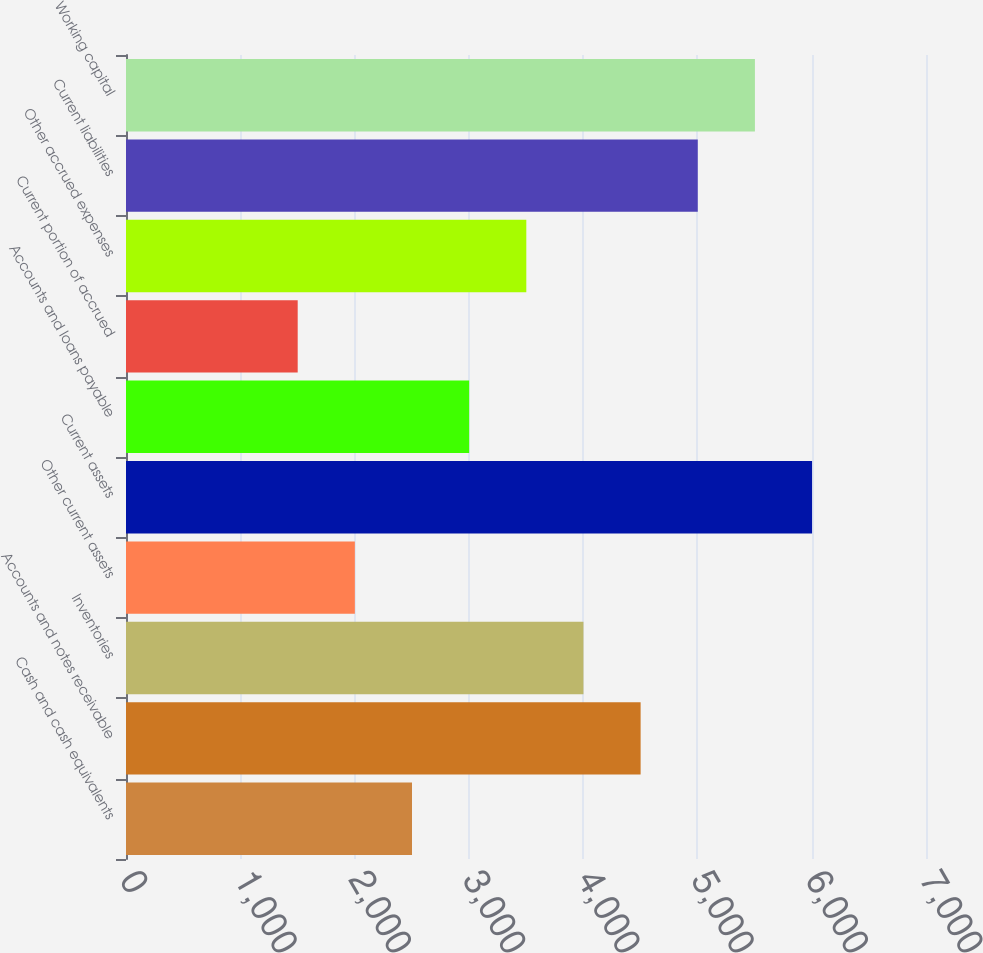<chart> <loc_0><loc_0><loc_500><loc_500><bar_chart><fcel>Cash and cash equivalents<fcel>Accounts and notes receivable<fcel>Inventories<fcel>Other current assets<fcel>Current assets<fcel>Accounts and loans payable<fcel>Current portion of accrued<fcel>Other accrued expenses<fcel>Current liabilities<fcel>Working capital<nl><fcel>2502.51<fcel>4502.87<fcel>4002.78<fcel>2002.42<fcel>6003.14<fcel>3002.6<fcel>1502.33<fcel>3502.69<fcel>5002.96<fcel>5503.05<nl></chart> 